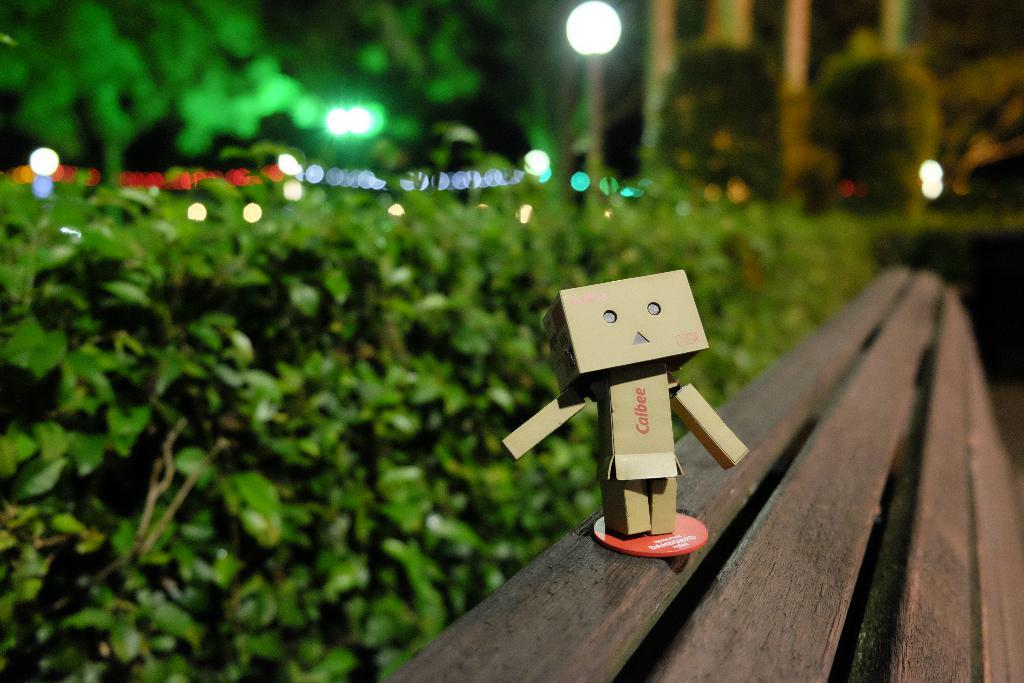What type of furniture is in the image? There is a wooden bench in the image. What is placed on the wooden bench? There is a toy on the bench. What type of vegetation is present in the image? There are green plants and trees in the image. What can be seen illuminating the area in the image? There are lights visible in the image. What type of spy equipment can be seen on the toy in the image? There is no spy equipment present on the toy in the image. How is the son related to the person who took the image? There is no information about a son or a person who took the image in the provided facts. 